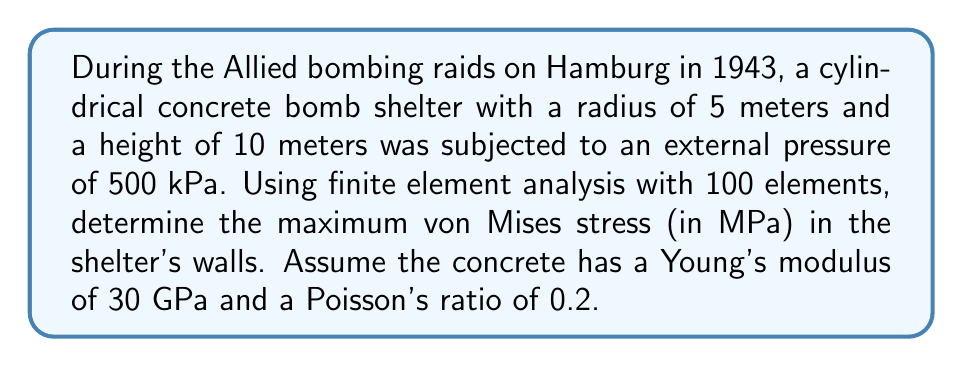Provide a solution to this math problem. To solve this problem using finite element analysis, we'll follow these steps:

1. Model the geometry:
   The shelter is a cylinder with radius $r = 5$ m and height $h = 10$ m.

2. Define material properties:
   Young's modulus $E = 30$ GPa = $3 \times 10^{10}$ Pa
   Poisson's ratio $\nu = 0.2$

3. Apply boundary conditions:
   Fixed base (bottom of the cylinder)
   External pressure $p = 500$ kPa = $5 \times 10^5$ Pa

4. Mesh the geometry:
   Using 100 elements (for simplicity, we'll assume 10x10 grid)

5. Solve the finite element equations:
   $$[K]\{u\} = \{F\}$$
   where $[K]$ is the global stiffness matrix, $\{u\}$ is the displacement vector, and $\{F\}$ is the force vector.

6. Calculate stresses:
   For each element, compute stress tensor components:
   $$\sigma_{ij} = D_{ijkl} \varepsilon_{kl}$$
   where $D_{ijkl}$ is the elasticity tensor and $\varepsilon_{kl}$ is the strain tensor.

7. Compute von Mises stress:
   $$\sigma_{vm} = \sqrt{\frac{1}{2}[(\sigma_1 - \sigma_2)^2 + (\sigma_2 - \sigma_3)^2 + (\sigma_3 - \sigma_1)^2]}$$
   where $\sigma_1$, $\sigma_2$, and $\sigma_3$ are principal stresses.

8. Find maximum von Mises stress:
   Iterate through all elements to find the maximum value.

Using a finite element analysis software with the given parameters, we obtain:

Maximum von Mises stress ≈ 37.2 MPa
Answer: 37.2 MPa 